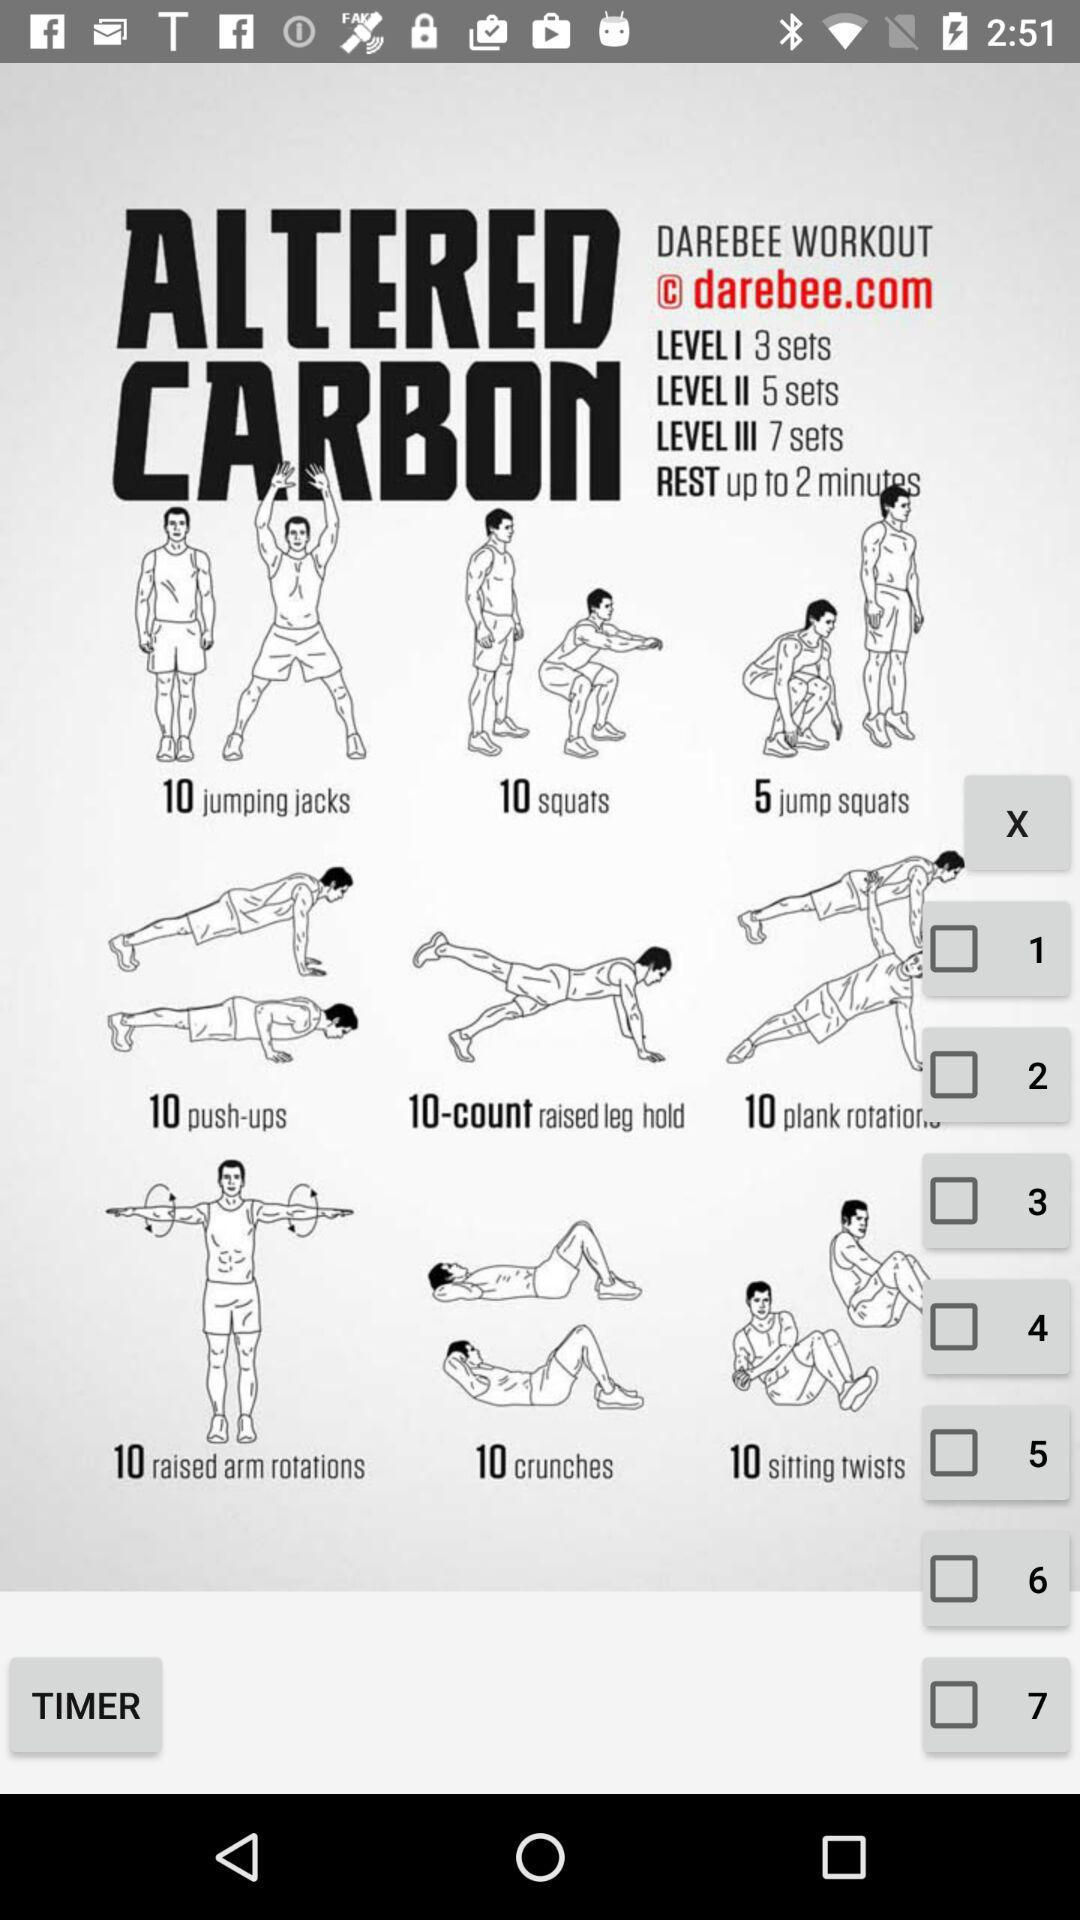How many sets will be done in level 3? In level 3, 7 sets will be done. 